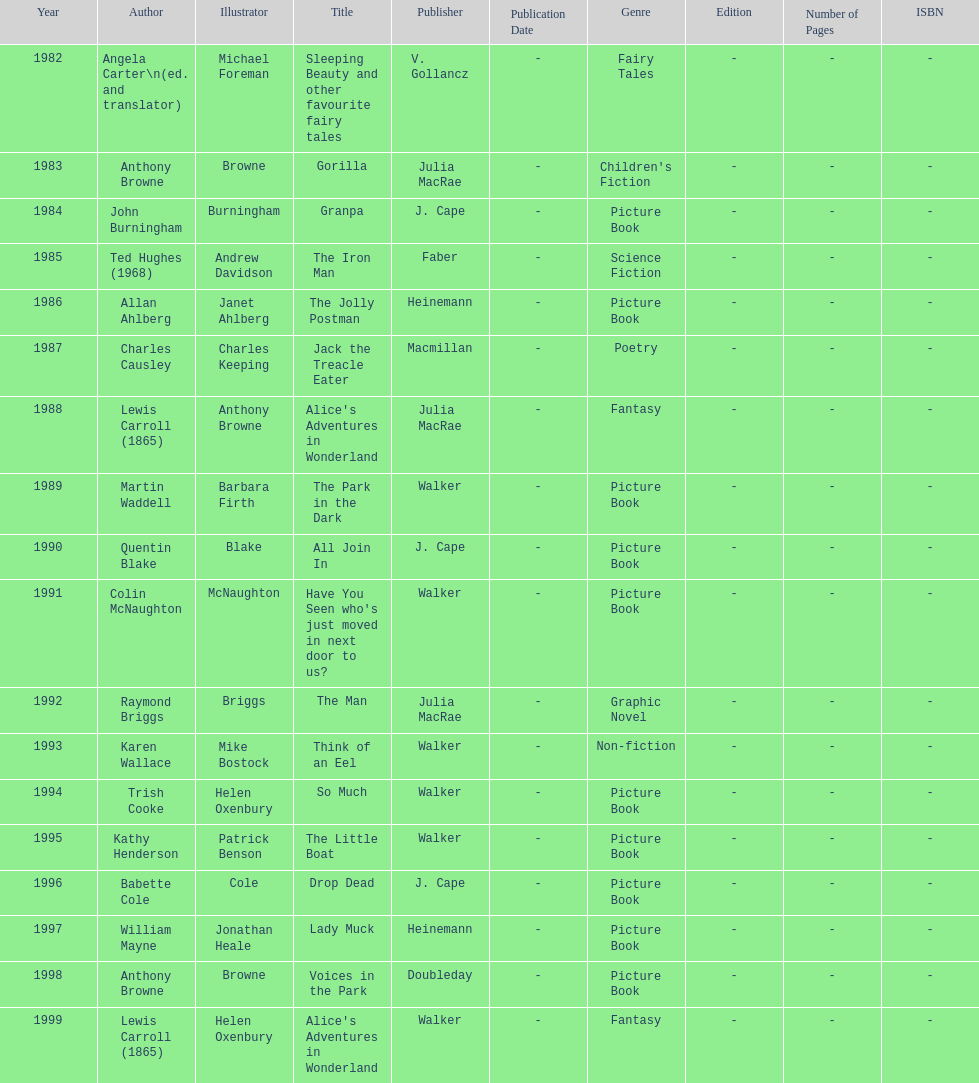How many total titles were published by walker? 5. 